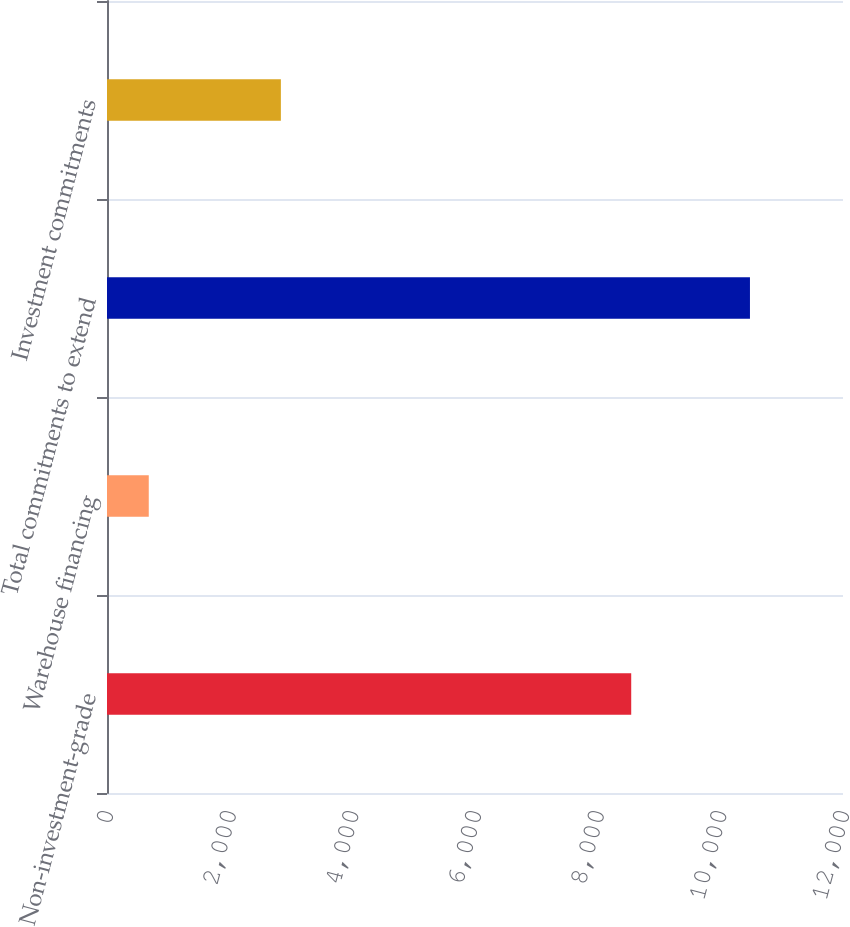Convert chart. <chart><loc_0><loc_0><loc_500><loc_500><bar_chart><fcel>Non-investment-grade<fcel>Warehouse financing<fcel>Total commitments to extend<fcel>Investment commitments<nl><fcel>8547<fcel>681<fcel>10483<fcel>2835<nl></chart> 